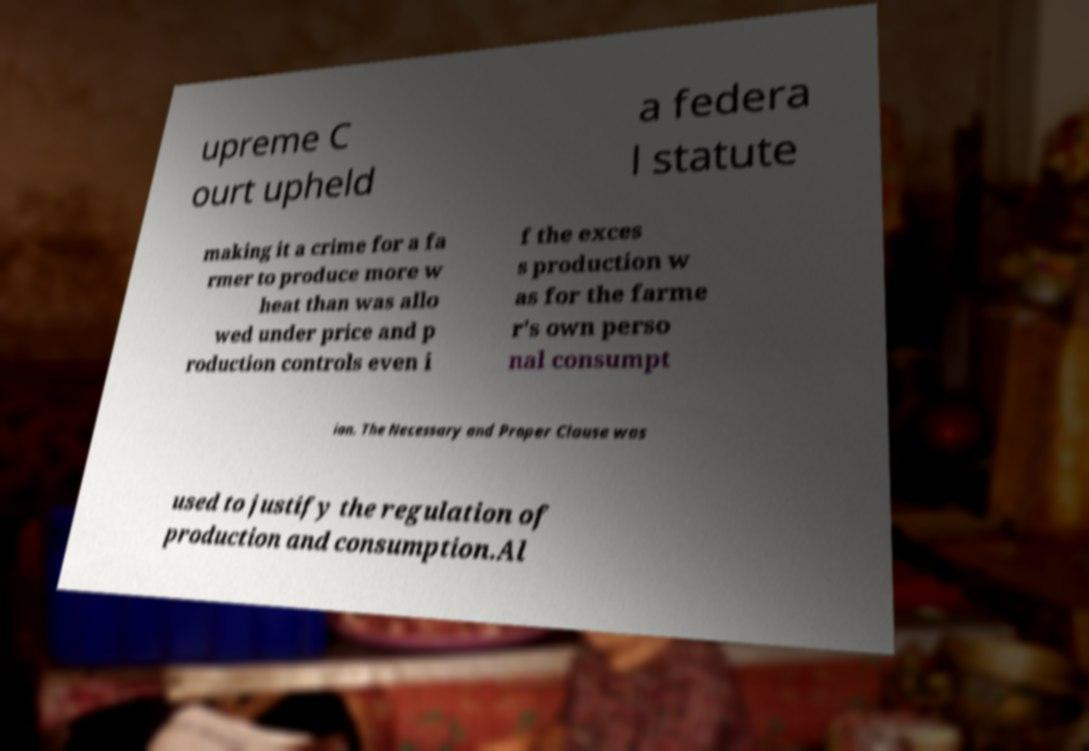Could you extract and type out the text from this image? upreme C ourt upheld a federa l statute making it a crime for a fa rmer to produce more w heat than was allo wed under price and p roduction controls even i f the exces s production w as for the farme r's own perso nal consumpt ion. The Necessary and Proper Clause was used to justify the regulation of production and consumption.Al 